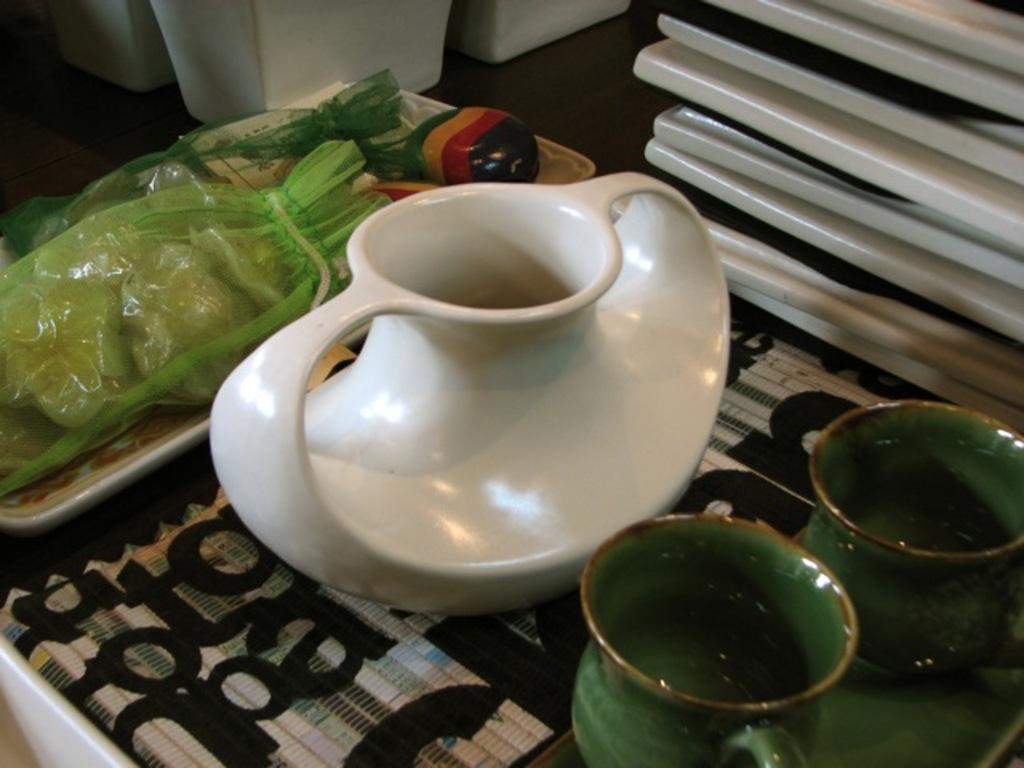How many cups can be seen in the image? There are two cups in the image. What other container is present in the image? There is a jug in the image. What is placed on the tray in the image? There are bags on the tray in the image. On what surface are the objects placed? The objects are placed on a surface. Where is the soap stored in the image? There is no soap present in the image. What type of drawer can be seen holding kitchen utensils in the image? There is no drawer visible in the image. 